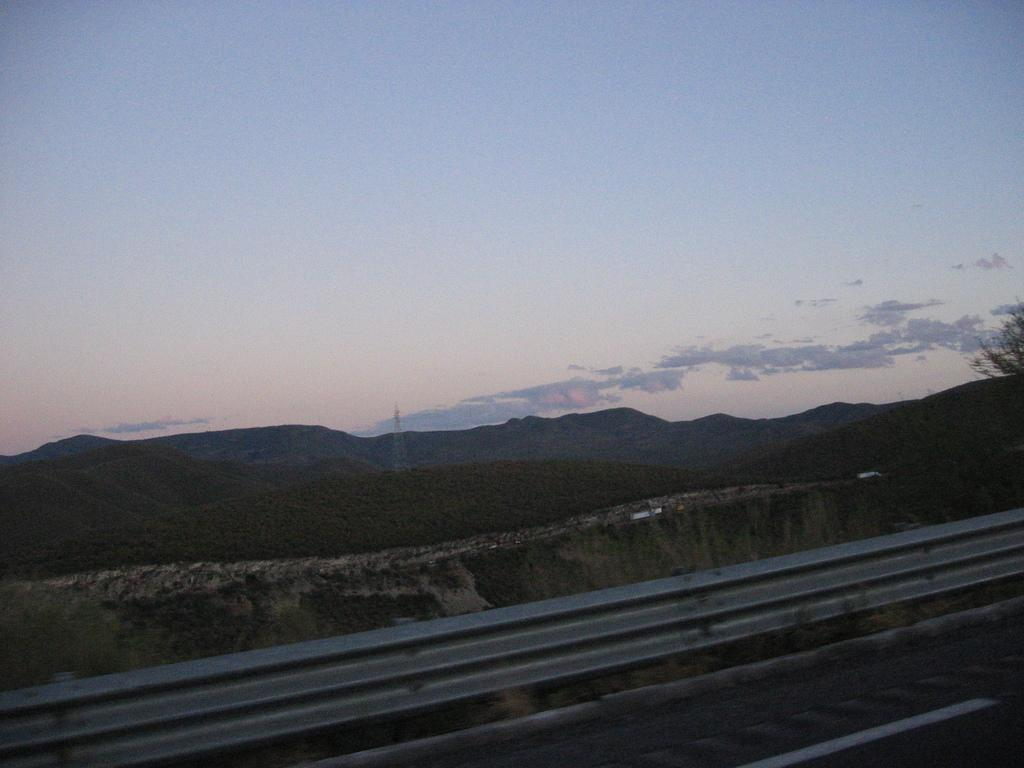What type of landscape feature can be seen in the image? There are hills in the image. What else is visible in the image besides the hills? The sky is visible in the image, as well as a road at the bottom and a tree on the right side. What type of pencil can be seen in the image? There is no pencil present in the image. What shape does the earth have in the image? The image does not depict the earth, so its shape cannot be determined. 